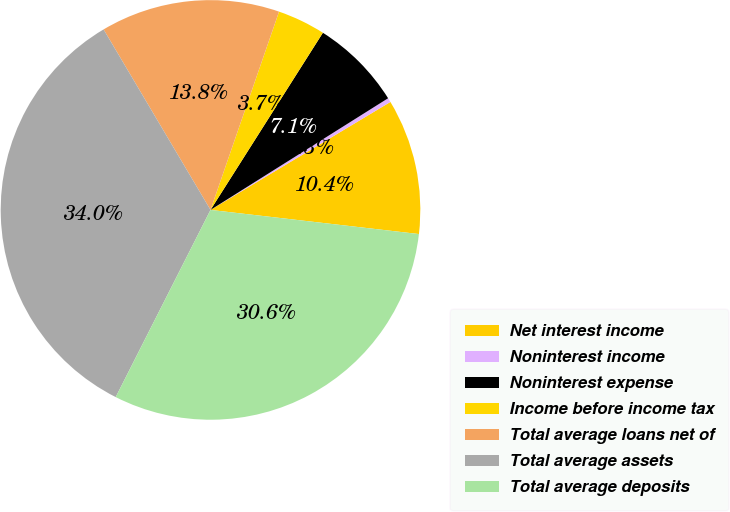Convert chart. <chart><loc_0><loc_0><loc_500><loc_500><pie_chart><fcel>Net interest income<fcel>Noninterest income<fcel>Noninterest expense<fcel>Income before income tax<fcel>Total average loans net of<fcel>Total average assets<fcel>Total average deposits<nl><fcel>10.44%<fcel>0.33%<fcel>7.07%<fcel>3.7%<fcel>13.81%<fcel>34.03%<fcel>30.63%<nl></chart> 